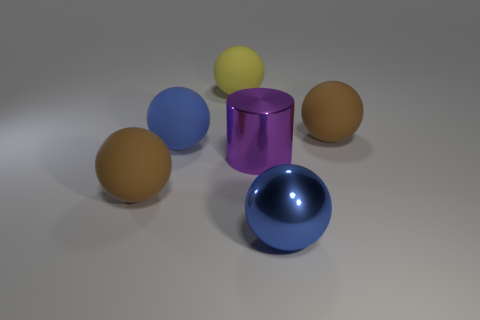Subtract all big metal spheres. How many spheres are left? 4 Subtract all blue spheres. How many spheres are left? 3 Subtract 4 spheres. How many spheres are left? 1 Add 1 purple shiny cylinders. How many objects exist? 7 Subtract all yellow cylinders. How many blue balls are left? 2 Subtract all large purple metal cylinders. Subtract all rubber objects. How many objects are left? 1 Add 2 big purple shiny cylinders. How many big purple shiny cylinders are left? 3 Add 3 large brown matte objects. How many large brown matte objects exist? 5 Subtract 0 yellow blocks. How many objects are left? 6 Subtract all spheres. How many objects are left? 1 